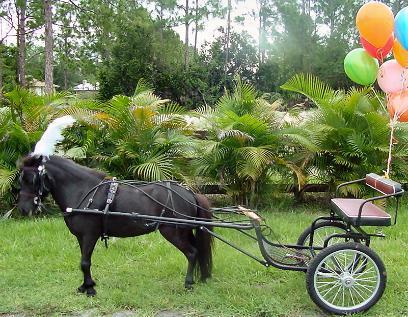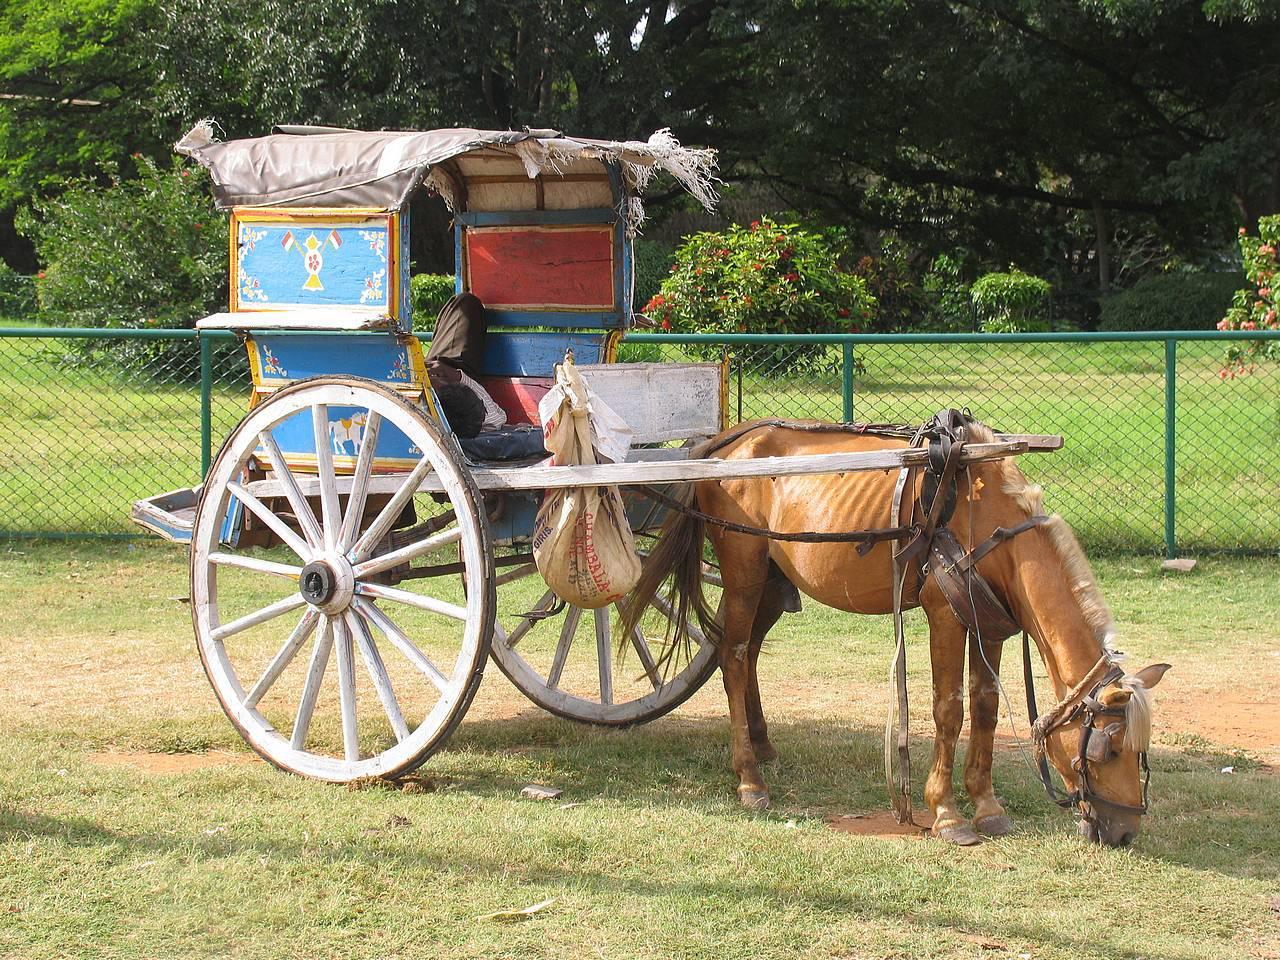The first image is the image on the left, the second image is the image on the right. Analyze the images presented: Is the assertion "Each image shows a wagon hitched to a brown horse." valid? Answer yes or no. No. 